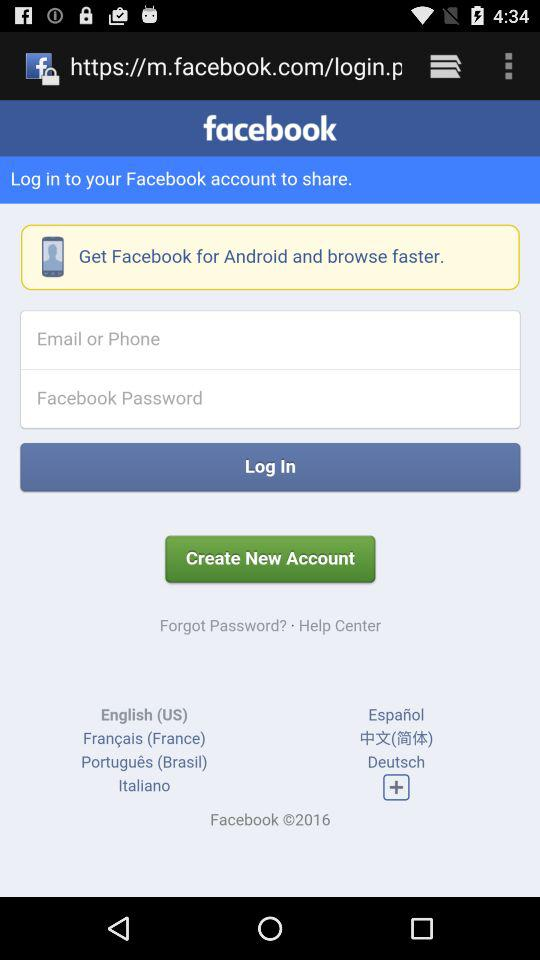What are the requirements to get a login? The requirements are "Email or Phone" and "Facebook Password". 